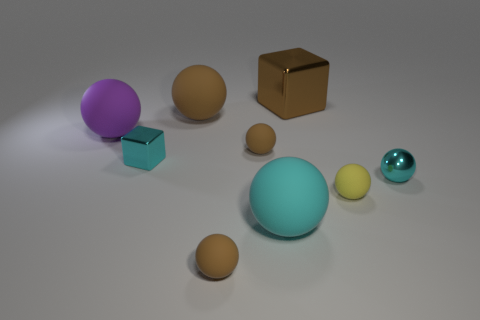There is a big brown object that is in front of the brown metallic thing; what is its material?
Give a very brief answer. Rubber. What number of other things are the same shape as the large cyan matte thing?
Keep it short and to the point. 6. Do the big purple thing and the big brown metallic thing have the same shape?
Provide a succinct answer. No. There is a tiny yellow rubber sphere; are there any small cyan metal balls behind it?
Your response must be concise. Yes. What number of things are tiny metal cubes or brown cubes?
Your answer should be very brief. 2. How many other things are there of the same size as the yellow matte thing?
Your answer should be very brief. 4. How many balls are both to the left of the big metallic thing and in front of the large purple matte object?
Keep it short and to the point. 3. Do the cyan thing right of the large shiny cube and the cyan sphere on the left side of the big brown cube have the same size?
Your answer should be compact. No. What is the size of the cyan object left of the big brown matte object?
Your response must be concise. Small. What number of things are large brown things in front of the brown metal object or small metallic objects that are left of the large cyan object?
Your answer should be very brief. 2. 